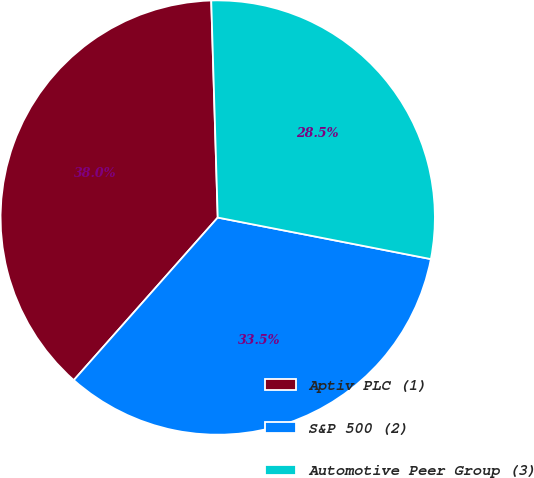Convert chart. <chart><loc_0><loc_0><loc_500><loc_500><pie_chart><fcel>Aptiv PLC (1)<fcel>S&P 500 (2)<fcel>Automotive Peer Group (3)<nl><fcel>37.99%<fcel>33.47%<fcel>28.54%<nl></chart> 